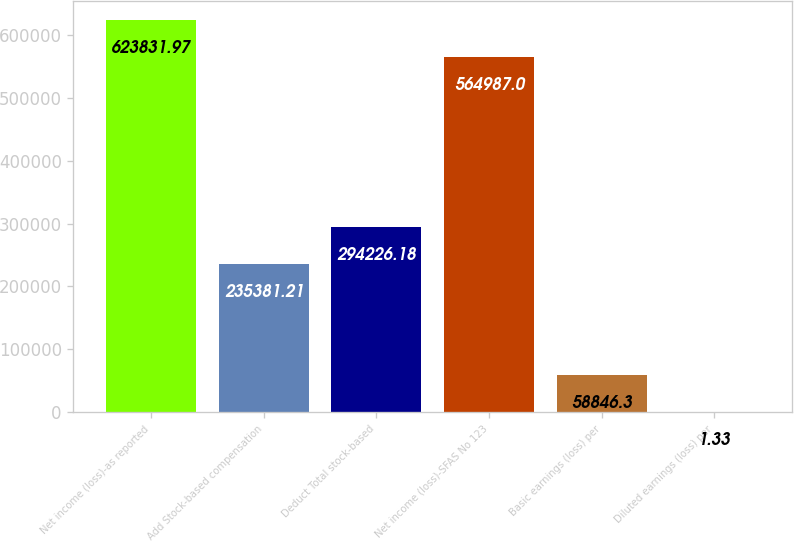Convert chart to OTSL. <chart><loc_0><loc_0><loc_500><loc_500><bar_chart><fcel>Net income (loss)-as reported<fcel>Add Stock-based compensation<fcel>Deduct Total stock-based<fcel>Net income (loss)-SFAS No 123<fcel>Basic earnings (loss) per<fcel>Diluted earnings (loss) per<nl><fcel>623832<fcel>235381<fcel>294226<fcel>564987<fcel>58846.3<fcel>1.33<nl></chart> 